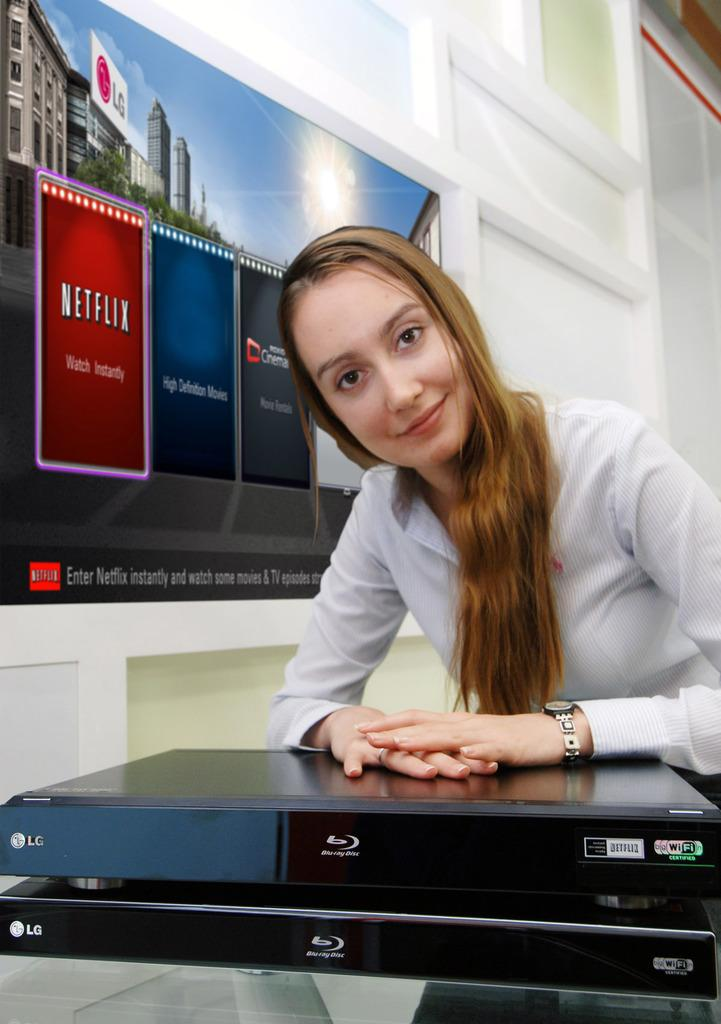<image>
Summarize the visual content of the image. A smiling woman rests her hands on top of an LG Blue Ray player. 